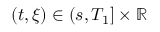<formula> <loc_0><loc_0><loc_500><loc_500>( t , \xi ) \in ( s , T _ { 1 } ] \times \mathbb { R }</formula> 